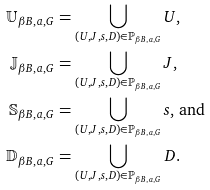<formula> <loc_0><loc_0><loc_500><loc_500>\mathbb { U } _ { \beta B , a , G } & = \bigcup _ { ( U , J , s , D ) \in \mathbb { P } _ { \beta B , a , G } } U , \\ \mathbb { J } _ { \beta B , a , G } & = \bigcup _ { ( U , J , s , D ) \in \mathbb { P } _ { \beta B , a , G } } J , \\ \mathbb { S } _ { \beta B , a , G } & = \bigcup _ { ( U , J , s , D ) \in \mathbb { P } _ { \beta B , a , G } } s \text {, and} \\ \mathbb { D } _ { \beta B , a , G } & = \bigcup _ { ( U , J , s , D ) \in \mathbb { P } _ { \beta B , a , G } } D .</formula> 